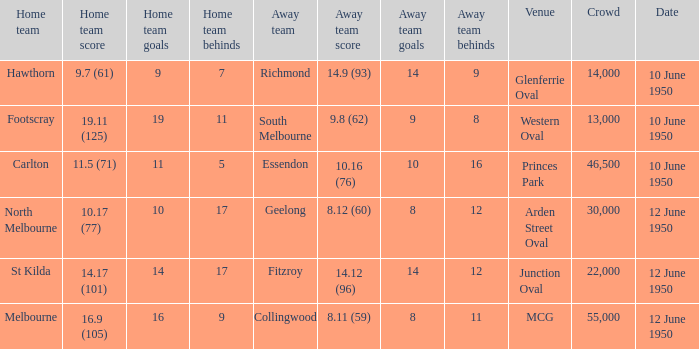Who was the away team when the VFL played at MCG? Collingwood. 